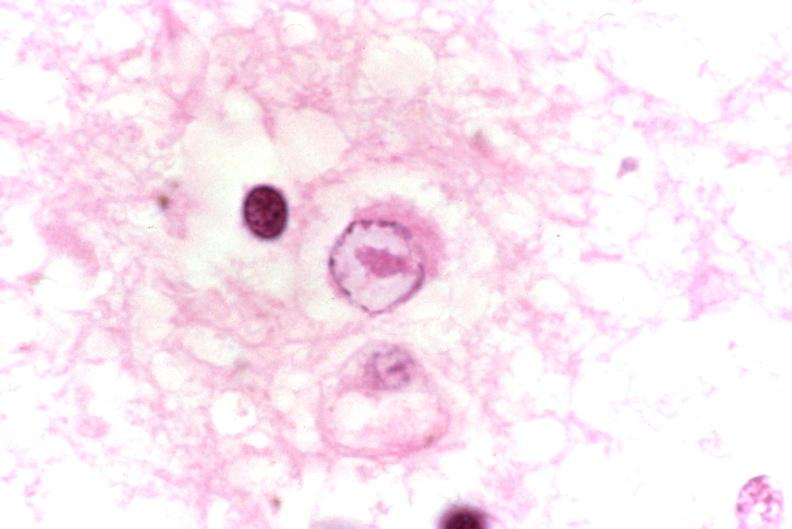s acute myelogenous leukemia present?
Answer the question using a single word or phrase. No 